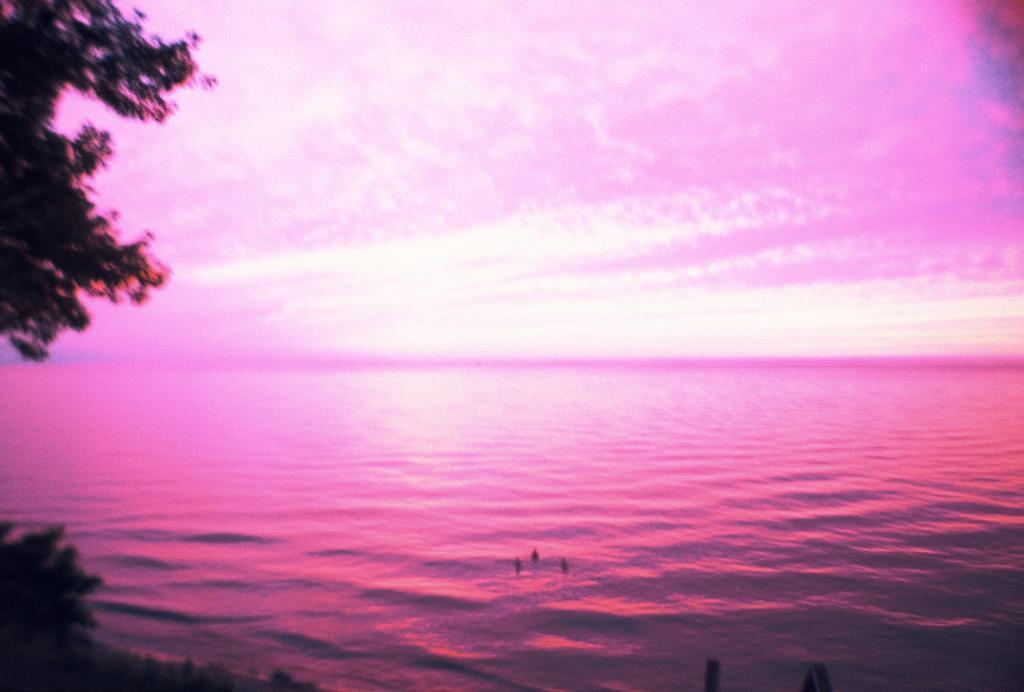Describe this image in one or two sentences. In this image there is an ocean in the middle. On the left side there are trees. This image looks in pink color. 